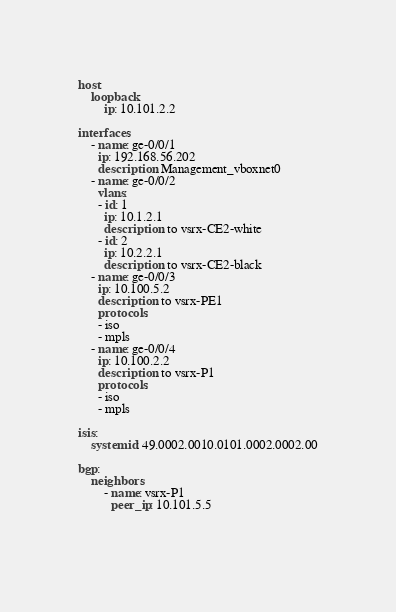Convert code to text. <code><loc_0><loc_0><loc_500><loc_500><_YAML_>
host:
    loopback:
        ip: 10.101.2.2

interfaces:
    - name: ge-0/0/1
      ip: 192.168.56.202
      description: Management_vboxnet0
    - name: ge-0/0/2
      vlans:
      - id: 1
        ip: 10.1.2.1
        description: to vsrx-CE2-white
      - id: 2
        ip: 10.2.2.1
        description: to vsrx-CE2-black
    - name: ge-0/0/3
      ip: 10.100.5.2
      description: to vsrx-PE1
      protocols:
      - iso
      - mpls      
    - name: ge-0/0/4
      ip: 10.100.2.2
      description: to vsrx-P1
      protocols:
      - iso
      - mpls
      
isis:
    systemid: 49.0002.0010.0101.0002.0002.00

bgp:
    neighbors:
        - name: vsrx-P1
          peer_ip: 10.101.5.5  

          
</code> 